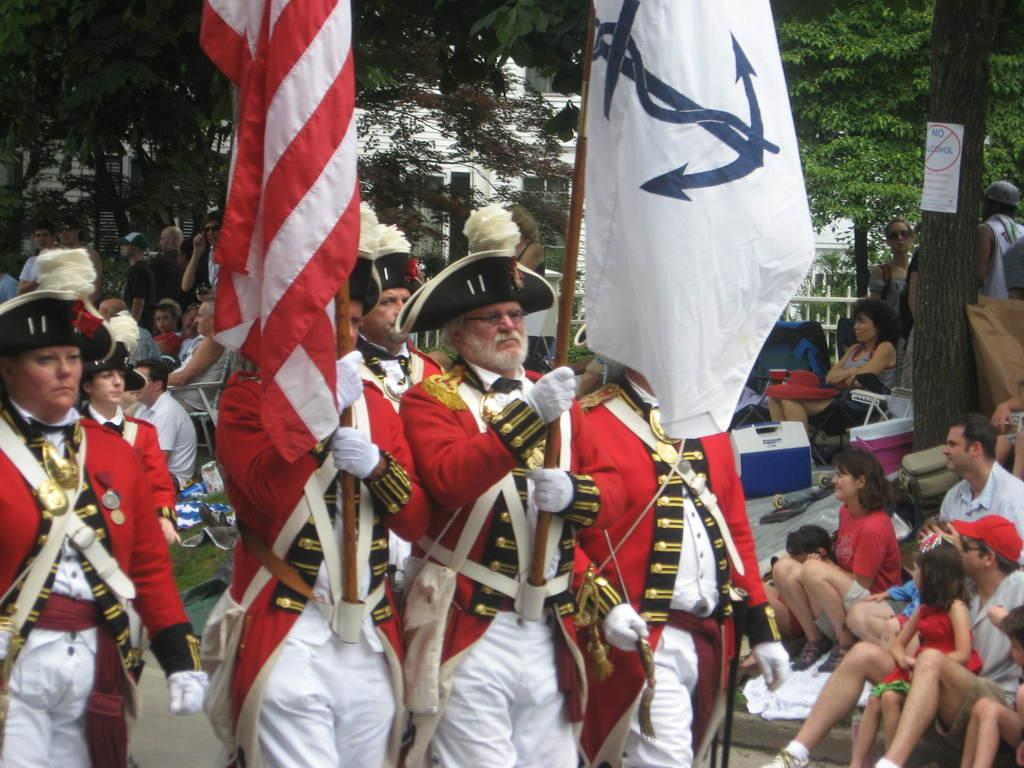What are the people in the image doing with the flags? The people in the image are holding flags. What else can be observed about the people in the image? Some people are sitting in the image. What can be seen in the background of the image? There are trees visible in the image. What is the poster with text in the image used for? The poster with text in the image is likely used for communication or conveying a message. What type of milk is being poured from the stem in the image? There is no milk or stem present in the image. How many bubbles can be seen floating around the people holding flags? There are no bubbles visible in the image. 